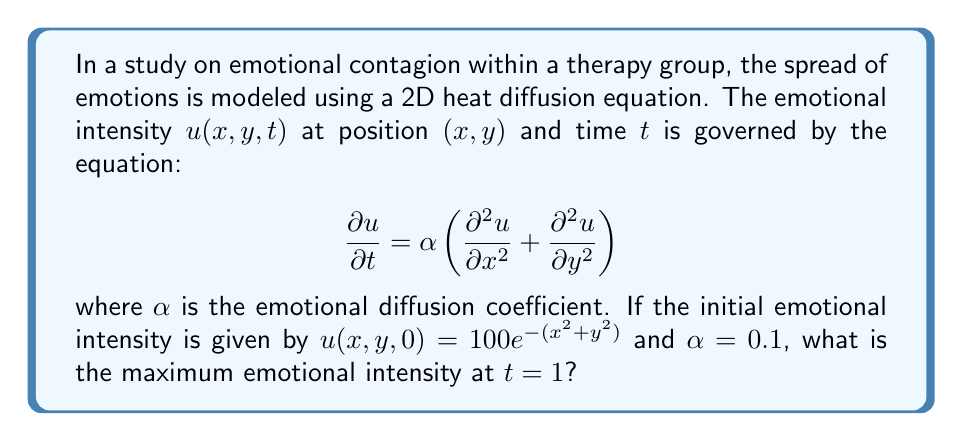Can you solve this math problem? To solve this problem, we'll use the solution to the 2D heat equation with an initial Gaussian distribution:

1) The general solution for the 2D heat equation with initial condition $u(x,y,0) = Ae^{-(x^2+y^2)/\sigma^2}$ is:

   $$u(x,y,t) = \frac{A\sigma^2}{4\alpha t + \sigma^2} \exp\left(-\frac{x^2+y^2}{4\alpha t + \sigma^2}\right)$$

2) In our case, $A = 100$, $\sigma^2 = 1$, and $\alpha = 0.1$. Substituting these values:

   $$u(x,y,t) = \frac{100}{0.4t + 1} \exp\left(-\frac{x^2+y^2}{0.4t + 1}\right)$$

3) At $t = 1$:

   $$u(x,y,1) = \frac{100}{1.4} \exp\left(-\frac{x^2+y^2}{1.4}\right)$$

4) The maximum intensity will occur at the center, where $x = y = 0$:

   $$u(0,0,1) = \frac{100}{1.4} \exp(0) = \frac{100}{1.4} \approx 71.43$$

Therefore, the maximum emotional intensity at $t = 1$ is approximately 71.43.
Answer: 71.43 